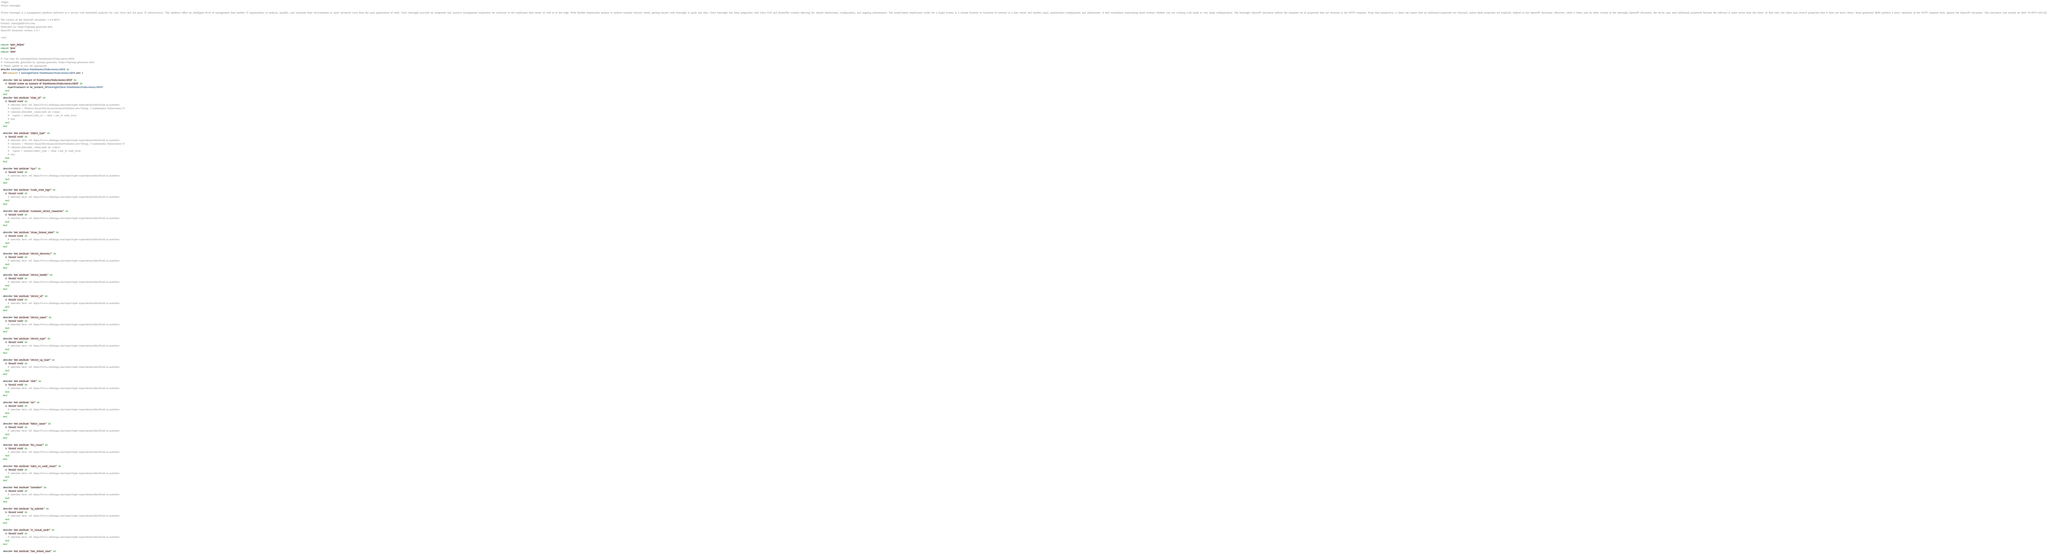Convert code to text. <code><loc_0><loc_0><loc_500><loc_500><_Ruby_>=begin
#Cisco Intersight

#Cisco Intersight is a management platform delivered as a service with embedded analytics for your Cisco and 3rd party IT infrastructure. This platform offers an intelligent level of management that enables IT organizations to analyze, simplify, and automate their environments in more advanced ways than the prior generations of tools. Cisco Intersight provides an integrated and intuitive management experience for resources in the traditional data center as well as at the edge. With flexible deployment options to address complex security needs, getting started with Intersight is quick and easy. Cisco Intersight has deep integration with Cisco UCS and HyperFlex systems allowing for remote deployment, configuration, and ongoing maintenance. The model-based deployment works for a single system in a remote location or hundreds of systems in a data center and enables rapid, standardized configuration and deployment. It also streamlines maintaining those systems whether you are working with small or very large configurations. The Intersight OpenAPI document defines the complete set of properties that are returned in the HTTP response. From that perspective, a client can expect that no additional properties are returned, unless these properties are explicitly defined in the OpenAPI document. However, when a client uses an older version of the Intersight OpenAPI document, the server may send additional properties because the software is more recent than the client. In that case, the client may receive properties that it does not know about. Some generated SDKs perform a strict validation of the HTTP response body against the OpenAPI document. This document was created on 2021-10-20T11:22:53Z.

The version of the OpenAPI document: 1.0.9-4870
Contact: intersight@cisco.com
Generated by: https://openapi-generator.tech
OpenAPI Generator version: 5.3.1

=end

require 'spec_helper'
require 'json'
require 'date'

# Unit tests for IntersightClient::NiatelemetryNiaInventoryAllOf
# Automatically generated by openapi-generator (https://openapi-generator.tech)
# Please update as you see appropriate
describe IntersightClient::NiatelemetryNiaInventoryAllOf do
  let(:instance) { IntersightClient::NiatelemetryNiaInventoryAllOf.new }

  describe 'test an instance of NiatelemetryNiaInventoryAllOf' do
    it 'should create an instance of NiatelemetryNiaInventoryAllOf' do
      expect(instance).to be_instance_of(IntersightClient::NiatelemetryNiaInventoryAllOf)
    end
  end
  describe 'test attribute "class_id"' do
    it 'should work' do
      # assertion here. ref: https://www.relishapp.com/rspec/rspec-expectations/docs/built-in-matchers
      # validator = Petstore::EnumTest::EnumAttributeValidator.new('String', ["niatelemetry.NiaInventory"])
      # validator.allowable_values.each do |value|
      #   expect { instance.class_id = value }.not_to raise_error
      # end
    end
  end

  describe 'test attribute "object_type"' do
    it 'should work' do
      # assertion here. ref: https://www.relishapp.com/rspec/rspec-expectations/docs/built-in-matchers
      # validator = Petstore::EnumTest::EnumAttributeValidator.new('String', ["niatelemetry.NiaInventory"])
      # validator.allowable_values.each do |value|
      #   expect { instance.object_type = value }.not_to raise_error
      # end
    end
  end

  describe 'test attribute "cpu"' do
    it 'should work' do
      # assertion here. ref: https://www.relishapp.com/rspec/rspec-expectations/docs/built-in-matchers
    end
  end

  describe 'test attribute "crash_reset_logs"' do
    it 'should work' do
      # assertion here. ref: https://www.relishapp.com/rspec/rspec-expectations/docs/built-in-matchers
    end
  end

  describe 'test attribute "customer_device_connector"' do
    it 'should work' do
      # assertion here. ref: https://www.relishapp.com/rspec/rspec-expectations/docs/built-in-matchers
    end
  end

  describe 'test attribute "dcnm_license_state"' do
    it 'should work' do
      # assertion here. ref: https://www.relishapp.com/rspec/rspec-expectations/docs/built-in-matchers
    end
  end

  describe 'test attribute "device_discovery"' do
    it 'should work' do
      # assertion here. ref: https://www.relishapp.com/rspec/rspec-expectations/docs/built-in-matchers
    end
  end

  describe 'test attribute "device_health"' do
    it 'should work' do
      # assertion here. ref: https://www.relishapp.com/rspec/rspec-expectations/docs/built-in-matchers
    end
  end

  describe 'test attribute "device_id"' do
    it 'should work' do
      # assertion here. ref: https://www.relishapp.com/rspec/rspec-expectations/docs/built-in-matchers
    end
  end

  describe 'test attribute "device_name"' do
    it 'should work' do
      # assertion here. ref: https://www.relishapp.com/rspec/rspec-expectations/docs/built-in-matchers
    end
  end

  describe 'test attribute "device_type"' do
    it 'should work' do
      # assertion here. ref: https://www.relishapp.com/rspec/rspec-expectations/docs/built-in-matchers
    end
  end

  describe 'test attribute "device_up_time"' do
    it 'should work' do
      # assertion here. ref: https://www.relishapp.com/rspec/rspec-expectations/docs/built-in-matchers
    end
  end

  describe 'test attribute "disk"' do
    it 'should work' do
      # assertion here. ref: https://www.relishapp.com/rspec/rspec-expectations/docs/built-in-matchers
    end
  end

  describe 'test attribute "dn"' do
    it 'should work' do
      # assertion here. ref: https://www.relishapp.com/rspec/rspec-expectations/docs/built-in-matchers
    end
  end

  describe 'test attribute "fabric_name"' do
    it 'should work' do
      # assertion here. ref: https://www.relishapp.com/rspec/rspec-expectations/docs/built-in-matchers
    end
  end

  describe 'test attribute "fex_count"' do
    it 'should work' do
      # assertion here. ref: https://www.relishapp.com/rspec/rspec-expectations/docs/built-in-matchers
    end
  end

  describe 'test attribute "infra_wi_node_count"' do
    it 'should work' do
      # assertion here. ref: https://www.relishapp.com/rspec/rspec-expectations/docs/built-in-matchers
    end
  end

  describe 'test attribute "interface"' do
    it 'should work' do
      # assertion here. ref: https://www.relishapp.com/rspec/rspec-expectations/docs/built-in-matchers
    end
  end

  describe 'test attribute "ip_address"' do
    it 'should work' do
      # assertion here. ref: https://www.relishapp.com/rspec/rspec-expectations/docs/built-in-matchers
    end
  end

  describe 'test attribute "is_virtual_node"' do
    it 'should work' do
      # assertion here. ref: https://www.relishapp.com/rspec/rspec-expectations/docs/built-in-matchers
    end
  end

  describe 'test attribute "last_reboot_time"' do</code> 